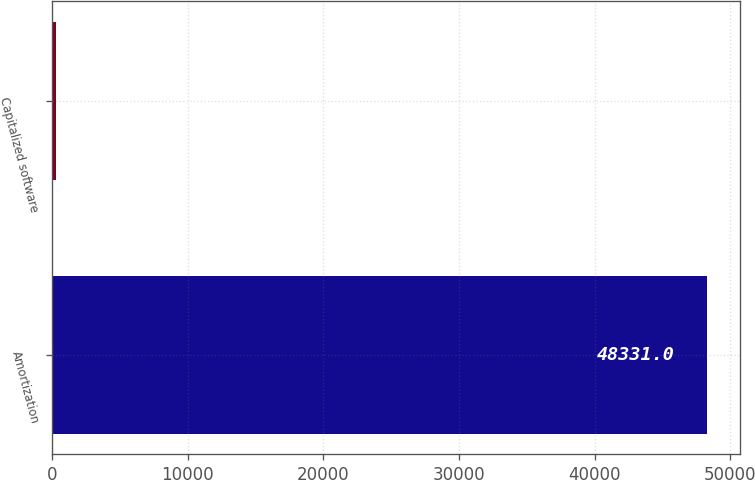Convert chart to OTSL. <chart><loc_0><loc_0><loc_500><loc_500><bar_chart><fcel>Amortization<fcel>Capitalized software<nl><fcel>48331<fcel>298<nl></chart> 